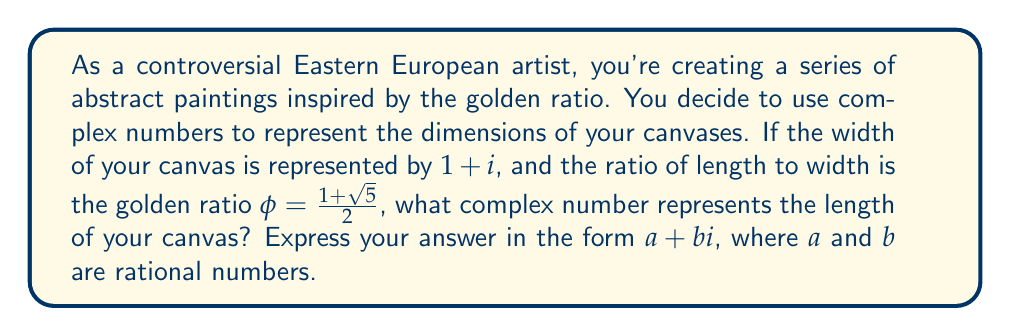What is the answer to this math problem? Let's approach this step-by-step:

1) The width of the canvas is given as $1 + i$.

2) The golden ratio $\phi$ is defined as:
   $$\phi = \frac{1 + \sqrt{5}}{2}$$

3) The length of the canvas should be $\phi$ times the width. So we need to multiply $(1 + i)$ by $\phi$:
   $$(1 + i) \cdot \frac{1 + \sqrt{5}}{2}$$

4) Let's distribute the fraction:
   $$\frac{1 + \sqrt{5}}{2} + \frac{1 + \sqrt{5}}{2}i$$

5) Simplify by separating the real and imaginary parts:
   $$\left(\frac{1 + \sqrt{5}}{2}\right) + \left(\frac{1 + \sqrt{5}}{2}\right)i$$

6) This is already in the form $a + bi$, where both $a$ and $b$ are equal to $\frac{1 + \sqrt{5}}{2}$.

7) We can't simplify this further while keeping $a$ and $b$ rational, as $\sqrt{5}$ is irrational.
Answer: $\frac{1 + \sqrt{5}}{2} + \frac{1 + \sqrt{5}}{2}i$ 